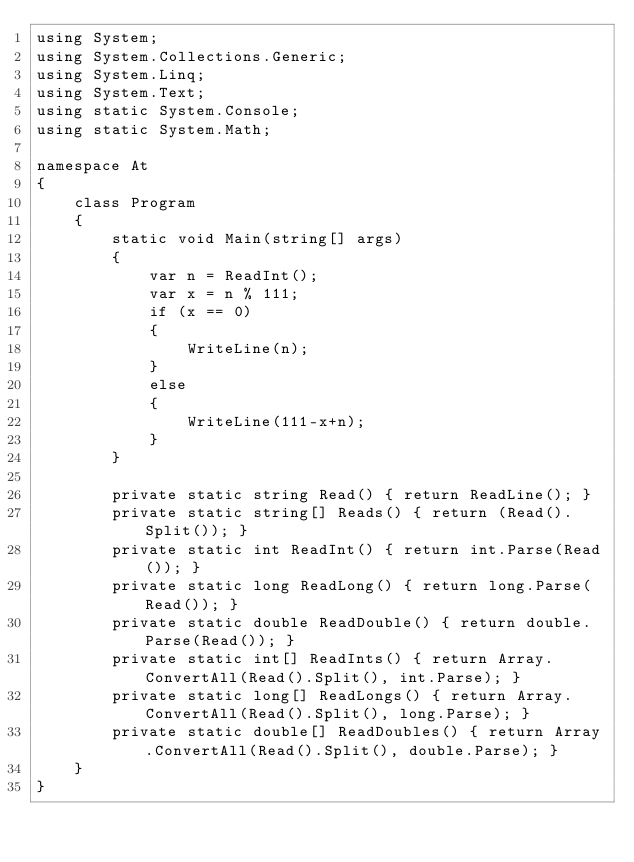Convert code to text. <code><loc_0><loc_0><loc_500><loc_500><_C#_>using System;
using System.Collections.Generic;
using System.Linq;
using System.Text;
using static System.Console;
using static System.Math;

namespace At
{
    class Program
    {
        static void Main(string[] args)
        {
            var n = ReadInt();
            var x = n % 111;
            if (x == 0)
            {
                WriteLine(n);
            }
            else
            {
                WriteLine(111-x+n);
            }
        }

        private static string Read() { return ReadLine(); }
        private static string[] Reads() { return (Read().Split()); }
        private static int ReadInt() { return int.Parse(Read()); }
        private static long ReadLong() { return long.Parse(Read()); }
        private static double ReadDouble() { return double.Parse(Read()); }
        private static int[] ReadInts() { return Array.ConvertAll(Read().Split(), int.Parse); }
        private static long[] ReadLongs() { return Array.ConvertAll(Read().Split(), long.Parse); }
        private static double[] ReadDoubles() { return Array.ConvertAll(Read().Split(), double.Parse); }
    }
}
</code> 